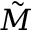<formula> <loc_0><loc_0><loc_500><loc_500>\tilde { M }</formula> 